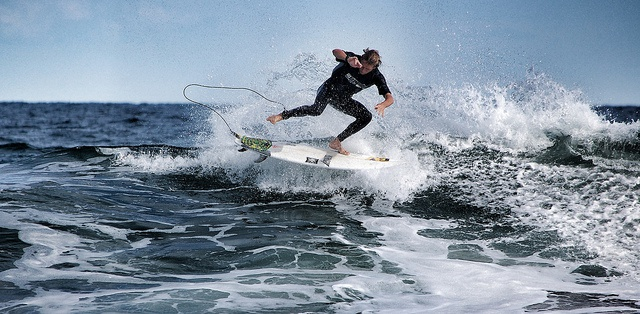Describe the objects in this image and their specific colors. I can see people in gray, black, and darkgray tones and surfboard in gray, lightgray, darkgray, and black tones in this image. 